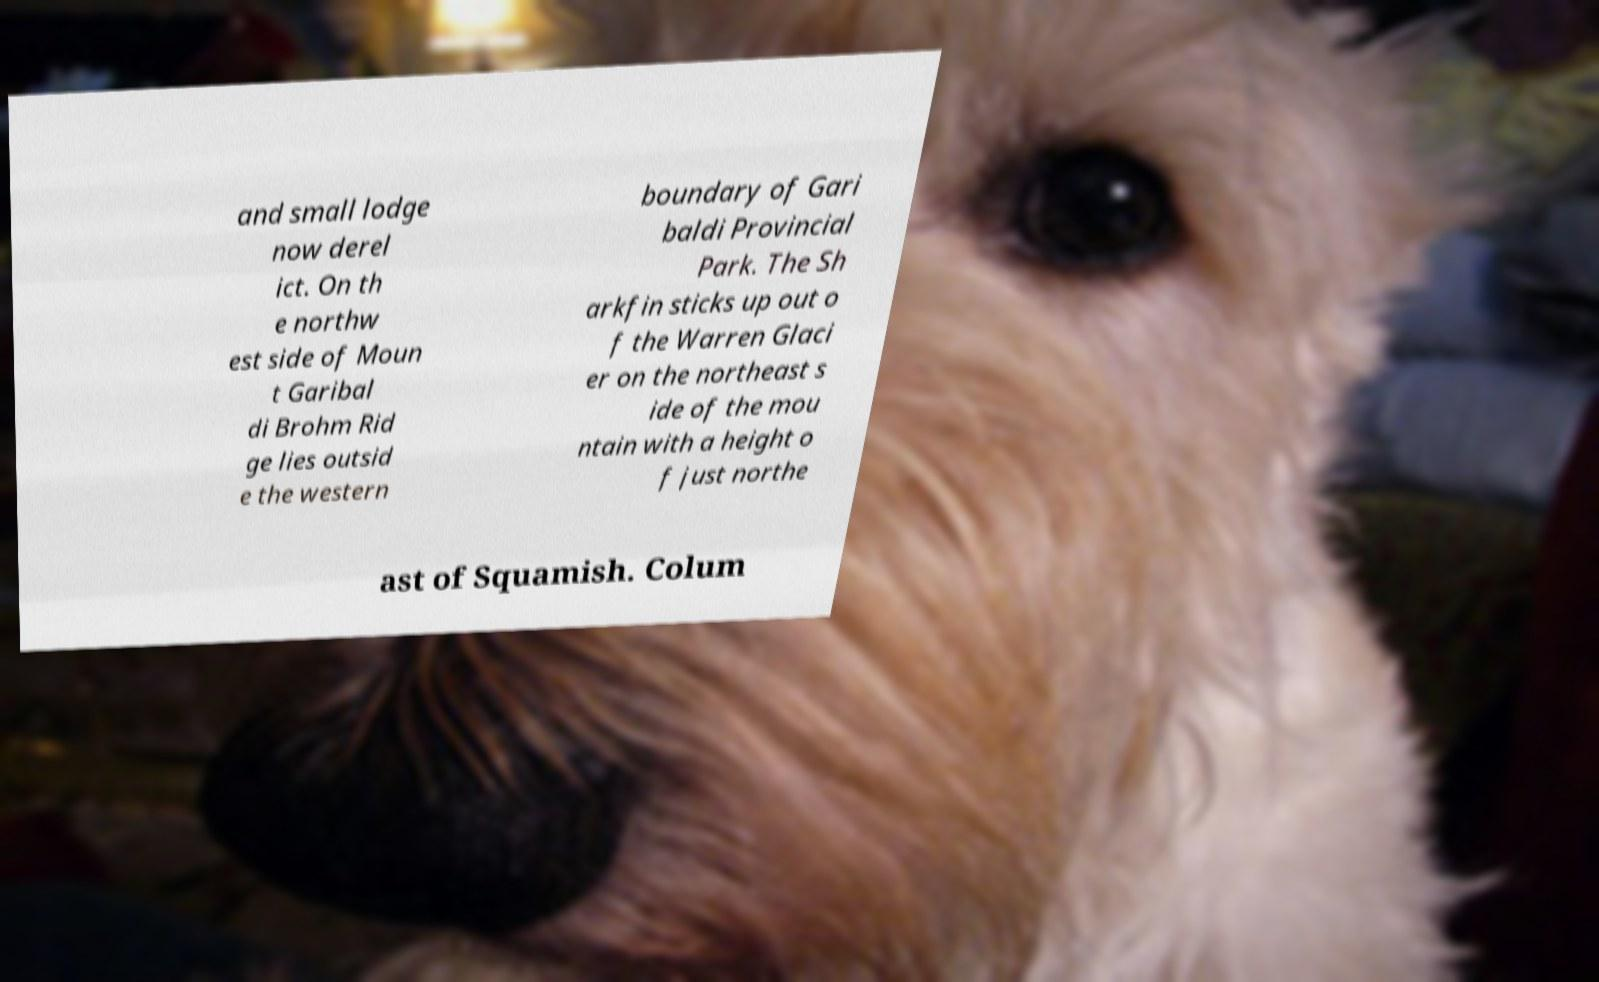There's text embedded in this image that I need extracted. Can you transcribe it verbatim? and small lodge now derel ict. On th e northw est side of Moun t Garibal di Brohm Rid ge lies outsid e the western boundary of Gari baldi Provincial Park. The Sh arkfin sticks up out o f the Warren Glaci er on the northeast s ide of the mou ntain with a height o f just northe ast of Squamish. Colum 